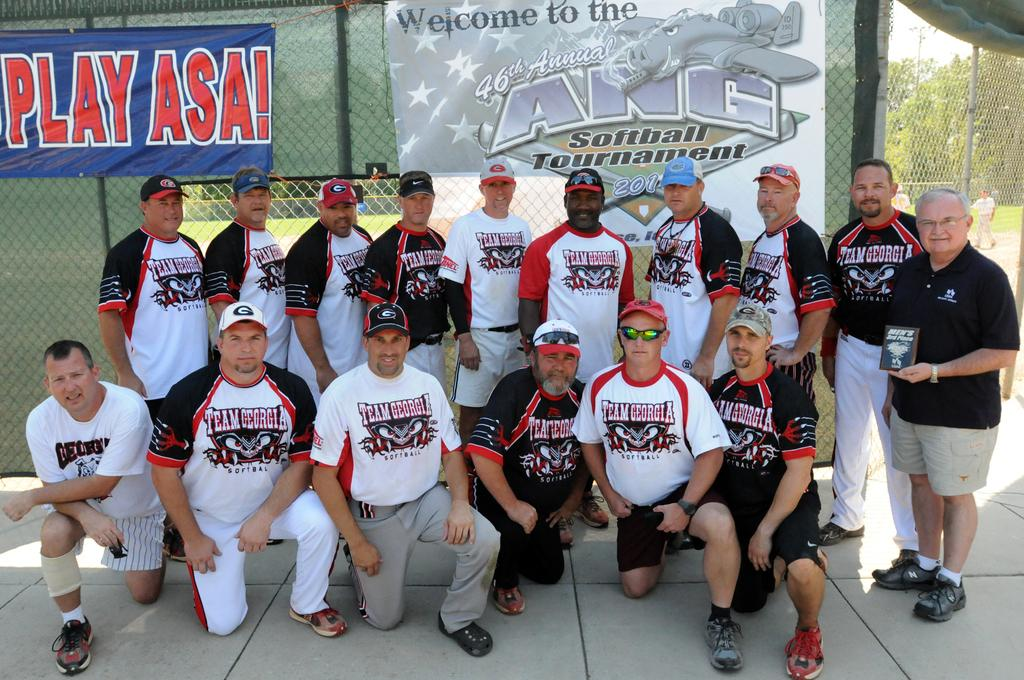<image>
Give a short and clear explanation of the subsequent image. A softball team takes a picture in front of the ANG tournament banner. 